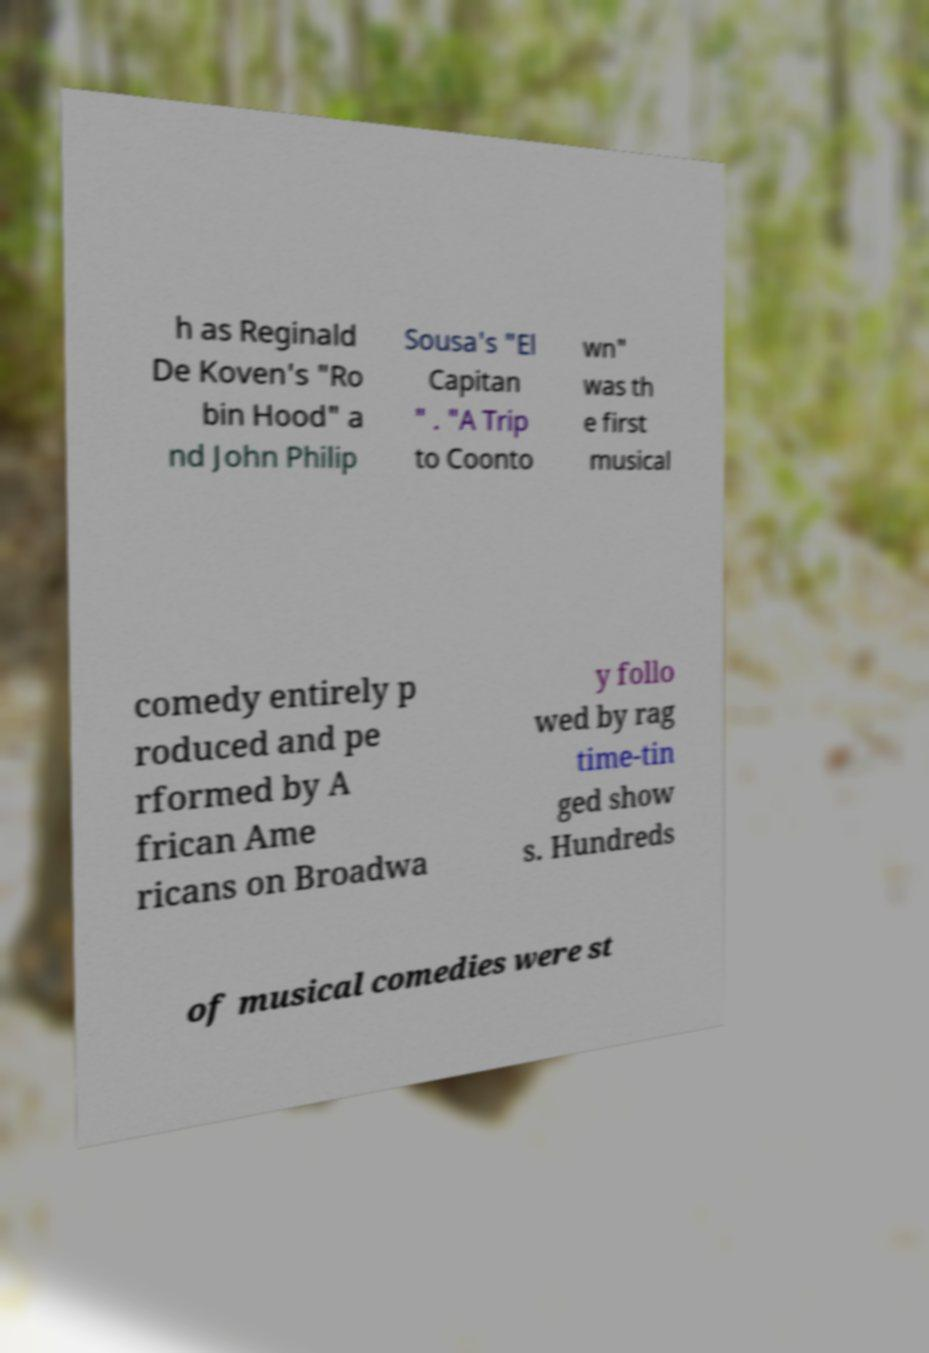Please identify and transcribe the text found in this image. h as Reginald De Koven's "Ro bin Hood" a nd John Philip Sousa's "El Capitan " . "A Trip to Coonto wn" was th e first musical comedy entirely p roduced and pe rformed by A frican Ame ricans on Broadwa y follo wed by rag time-tin ged show s. Hundreds of musical comedies were st 